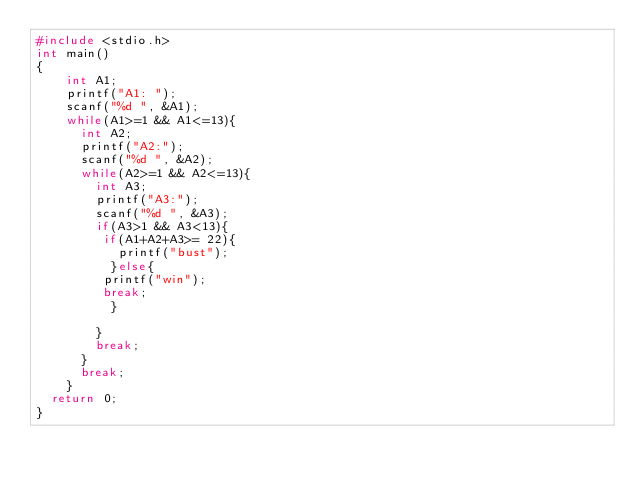Convert code to text. <code><loc_0><loc_0><loc_500><loc_500><_C++_>#include <stdio.h>
int main()
{
    int A1;
    printf("A1: ");
    scanf("%d ", &A1);
    while(A1>=1 && A1<=13){
      int A2;
      printf("A2:");
      scanf("%d ", &A2);
      while(A2>=1 && A2<=13){
        int A3;
        printf("A3:");
        scanf("%d ", &A3);
        if(A3>1 && A3<13){
         if(A1+A2+A3>= 22){
           printf("bust");
          }else{
         printf("win");
         break;
          }

        }
        break;
      }
      break;
    }
  return 0;
}</code> 